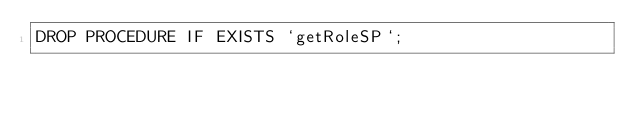Convert code to text. <code><loc_0><loc_0><loc_500><loc_500><_SQL_>DROP PROCEDURE IF EXISTS `getRoleSP`;

</code> 